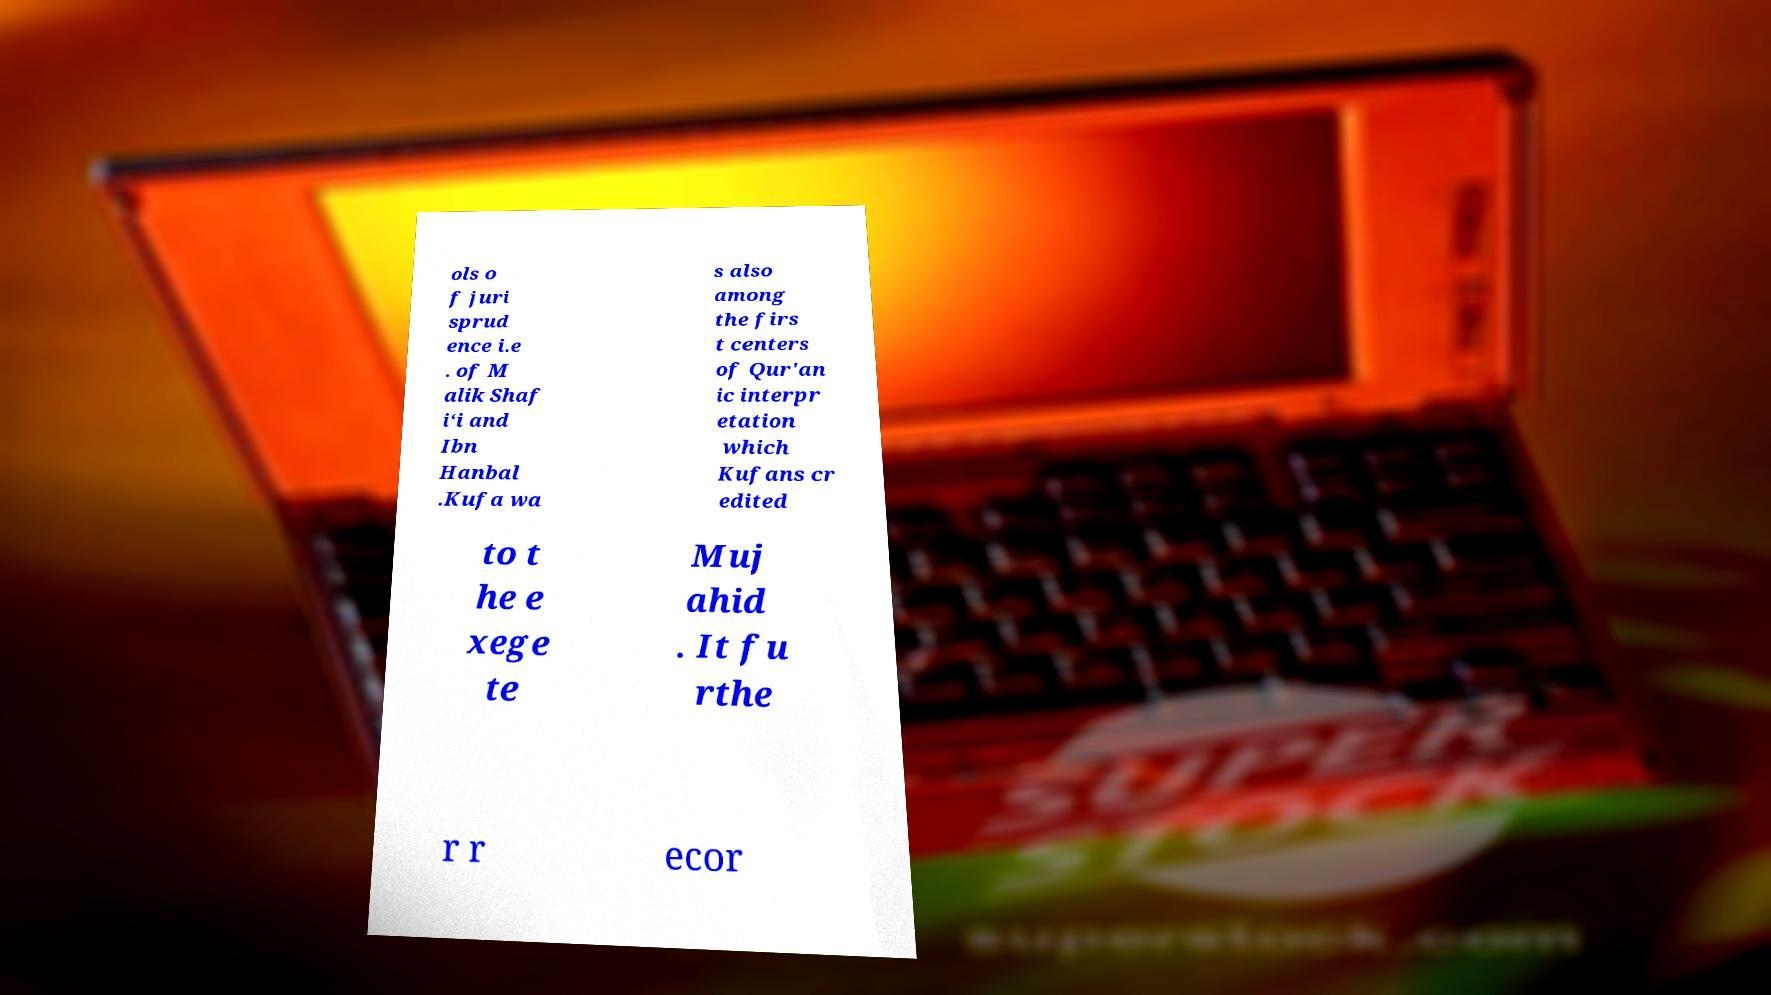Please identify and transcribe the text found in this image. ols o f juri sprud ence i.e . of M alik Shaf i‘i and Ibn Hanbal .Kufa wa s also among the firs t centers of Qur'an ic interpr etation which Kufans cr edited to t he e xege te Muj ahid . It fu rthe r r ecor 